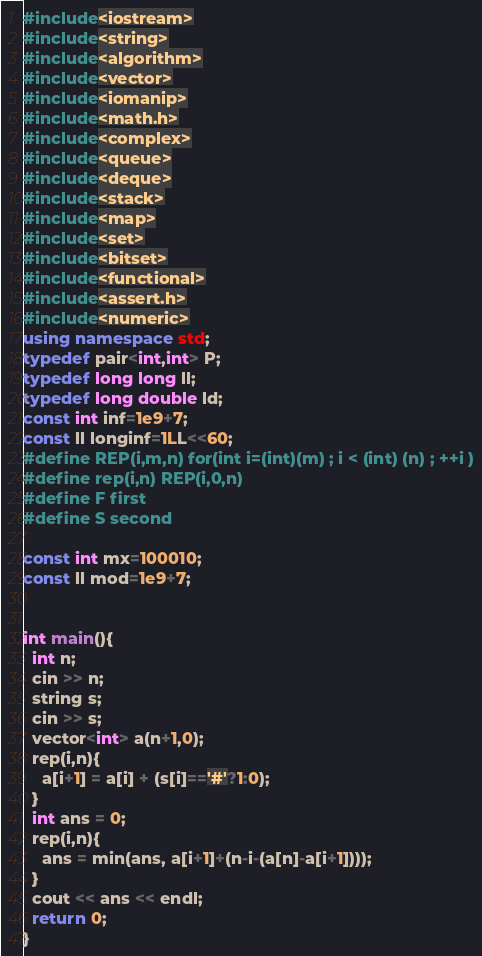<code> <loc_0><loc_0><loc_500><loc_500><_C++_>#include<iostream>
#include<string>
#include<algorithm>
#include<vector>
#include<iomanip>
#include<math.h>
#include<complex>
#include<queue>
#include<deque>
#include<stack>
#include<map>
#include<set>
#include<bitset>
#include<functional>
#include<assert.h>
#include<numeric>
using namespace std;
typedef pair<int,int> P;
typedef long long ll;
typedef long double ld;
const int inf=1e9+7;
const ll longinf=1LL<<60;
#define REP(i,m,n) for(int i=(int)(m) ; i < (int) (n) ; ++i )
#define rep(i,n) REP(i,0,n)
#define F first
#define S second

const int mx=100010;
const ll mod=1e9+7;


int main(){
  int n;
  cin >> n;
  string s;
  cin >> s;
  vector<int> a(n+1,0);
  rep(i,n){
    a[i+1] = a[i] + (s[i]=='#'?1:0);
  }
  int ans = 0;
  rep(i,n){
    ans = min(ans, a[i+1]+(n-i-(a[n]-a[i+1])));
  }
  cout << ans << endl;
  return 0;
}</code> 